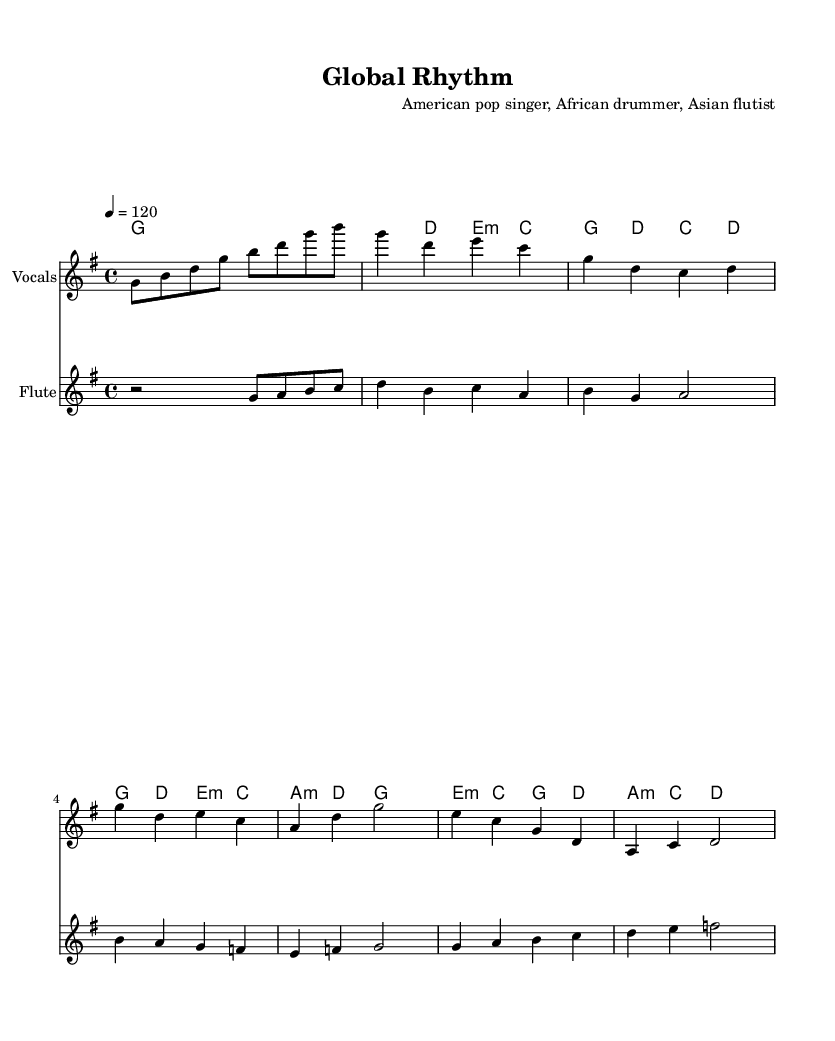What is the key signature of this music? The key signature is G major, which has one sharp (F#). In the sheet music, this is indicated at the beginning near the clef symbol.
Answer: G major What is the time signature used in this sheet music? The time signature is 4/4, meaning there are four beats per measure, and the quarter note gets one beat. This is displayed at the beginning of the score.
Answer: 4/4 What is the tempo marking for this piece? The tempo marking is 120 beats per minute, indicated by the number 4 = 120 in the score. This means the quarter note should be played at 120 beats per minute.
Answer: 120 How many measures are there in the verse section? The verse section contains two measures, identifiable by the layout of the melody and harmonies which show the verse notation. Each line of music typically represents a specific phrase or section, and here we can see two complete measures dedicated to the verse.
Answer: 2 What is the last chord played in the bridge? The last chord in the bridge is D major, indicated by the chord notation written above the staff and the arrangement of notes in the harmonies. The bridge is the final section and ends with the D major chord.
Answer: D major Which instrument plays the main melody in this score? The main melody is played by the vocals, as indicated under the staff labeled "Vocals." This is where the primary melody line is notated.
Answer: Vocals What kind of collaboration is showcased in this piece? This piece showcases a collaboration between an American pop singer, an African drummer, and an Asian flutist as noted in the composer section at the beginning for diverse representation.
Answer: International collaboration 